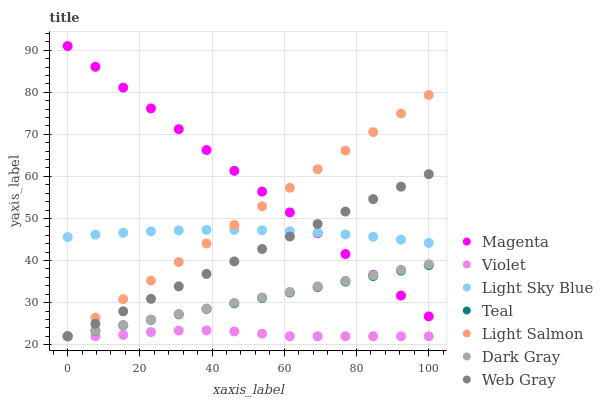Does Violet have the minimum area under the curve?
Answer yes or no. Yes. Does Magenta have the maximum area under the curve?
Answer yes or no. Yes. Does Web Gray have the minimum area under the curve?
Answer yes or no. No. Does Web Gray have the maximum area under the curve?
Answer yes or no. No. Is Dark Gray the smoothest?
Answer yes or no. Yes. Is Violet the roughest?
Answer yes or no. Yes. Is Web Gray the smoothest?
Answer yes or no. No. Is Web Gray the roughest?
Answer yes or no. No. Does Light Salmon have the lowest value?
Answer yes or no. Yes. Does Light Sky Blue have the lowest value?
Answer yes or no. No. Does Magenta have the highest value?
Answer yes or no. Yes. Does Web Gray have the highest value?
Answer yes or no. No. Is Violet less than Magenta?
Answer yes or no. Yes. Is Magenta greater than Violet?
Answer yes or no. Yes. Does Magenta intersect Light Salmon?
Answer yes or no. Yes. Is Magenta less than Light Salmon?
Answer yes or no. No. Is Magenta greater than Light Salmon?
Answer yes or no. No. Does Violet intersect Magenta?
Answer yes or no. No. 